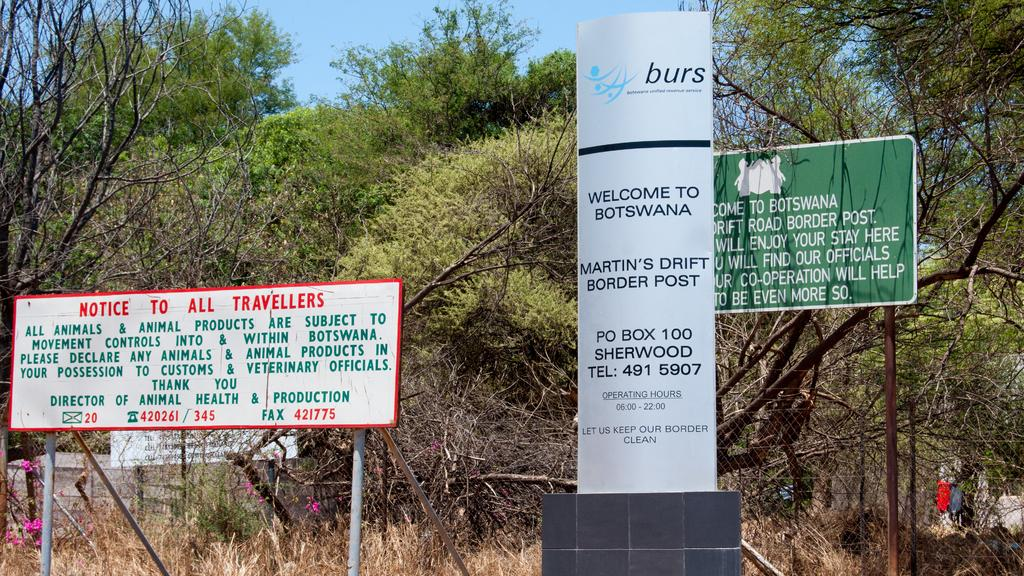What type of structures can be seen in the image? There are boards, poles, and net fencing in the image. What type of vegetation is present in the image? There are trees and dry grass in the image. What type of flowers can be seen in the image? There are pink color flowers in the image. What is visible in the background of the image? The sky is visible in the image. Can you tell me how many cherries are hanging from the trees in the image? There are no cherries present in the image; it features pink color flowers instead. What letters are written on the boards in the image? There are no letters written on the boards in the image; only the structures and objects mentioned in the facts are present. 